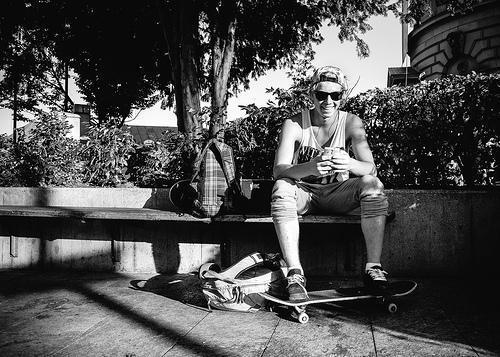How many people are in this picture?
Give a very brief answer. 1. 